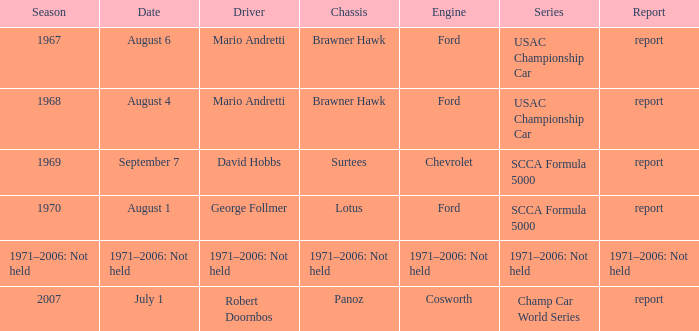Which motor powers the usac championship car? Ford, Ford. 